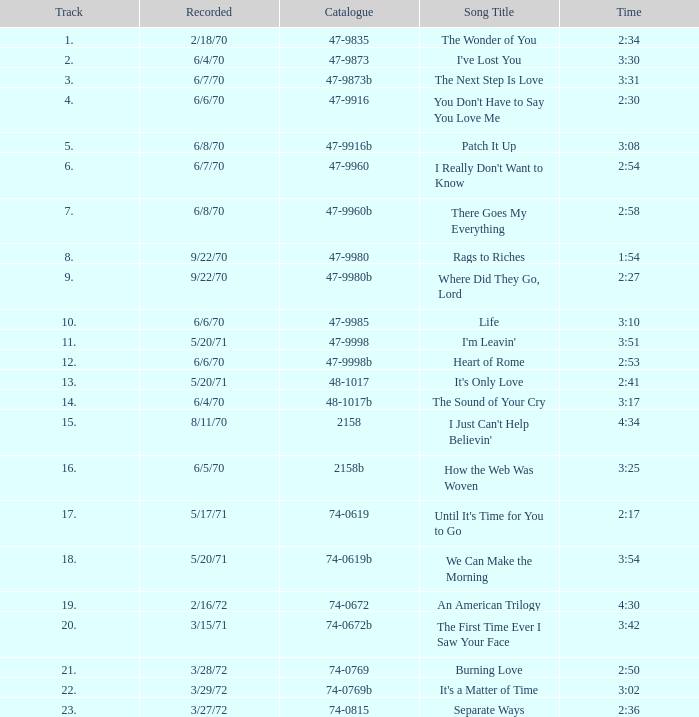What is the highest track for Burning Love? 21.0. 